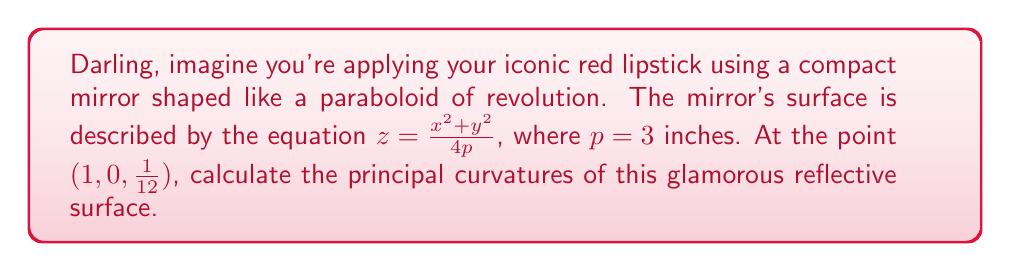Provide a solution to this math problem. Let's approach this step-by-step, sugar:

1) For a surface $z = f(x,y)$, the principal curvatures are given by:

   $$\kappa_1, \kappa_2 = H \pm \sqrt{H^2 - K}$$

   where $H$ is the mean curvature and $K$ is the Gaussian curvature.

2) We need to calculate the first and second partial derivatives:
   
   $f_x = \frac{x}{2p}, f_y = \frac{y}{2p}, f_{xx} = \frac{1}{2p}, f_{yy} = \frac{1}{2p}, f_{xy} = 0$

3) The mean curvature $H$ is given by:

   $$H = \frac{(1+f_y^2)f_{xx} - 2f_xf_yf_{xy} + (1+f_x^2)f_{yy}}{2(1+f_x^2+f_y^2)^{3/2}}$$

4) The Gaussian curvature $K$ is given by:

   $$K = \frac{f_{xx}f_{yy} - f_{xy}^2}{(1+f_x^2+f_y^2)^2}$$

5) At the point (1, 0, 1/12), we have:
   
   $f_x = \frac{1}{6}, f_y = 0, f_{xx} = f_{yy} = \frac{1}{6}, f_{xy} = 0$

6) Substituting these values:

   $$H = \frac{(1+0^2)\frac{1}{6} - 2\frac{1}{6}(0)(0) + (1+(\frac{1}{6})^2)\frac{1}{6}}{2(1+(\frac{1}{6})^2+0^2)^{3/2}} = \frac{1}{6\sqrt{37}}$$

   $$K = \frac{\frac{1}{6} \cdot \frac{1}{6} - 0^2}{(1+(\frac{1}{6})^2+0^2)^2} = \frac{1}{36 \cdot 37}$$

7) Now we can calculate the principal curvatures:

   $$\kappa_1, \kappa_2 = \frac{1}{6\sqrt{37}} \pm \sqrt{(\frac{1}{6\sqrt{37}})^2 - \frac{1}{36 \cdot 37}}$$

8) Simplifying:

   $$\kappa_1 = \frac{1}{6\sqrt{37}} + \frac{1}{6\sqrt{37}} = \frac{1}{3\sqrt{37}}$$
   $$\kappa_2 = \frac{1}{6\sqrt{37}} - \frac{1}{6\sqrt{37}} = 0$$
Answer: $\kappa_1 = \frac{1}{3\sqrt{37}}, \kappa_2 = 0$ 